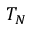<formula> <loc_0><loc_0><loc_500><loc_500>T _ { N }</formula> 